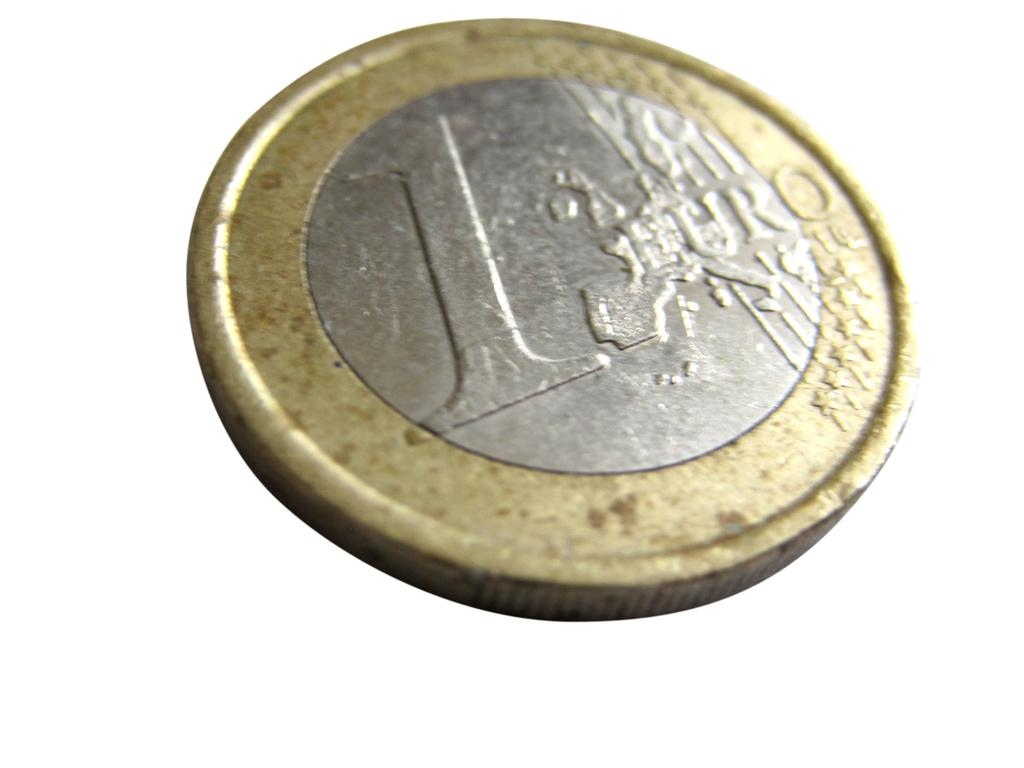<image>
Describe the image concisely. 1 Euro is stamped onto the face of this coin. 